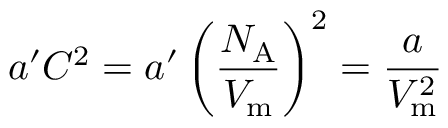<formula> <loc_0><loc_0><loc_500><loc_500>a ^ { \prime } C ^ { 2 } = a ^ { \prime } \left ( { \frac { N _ { A } } { V _ { m } } } \right ) ^ { 2 } = { \frac { a } { V _ { m } ^ { 2 } } }</formula> 